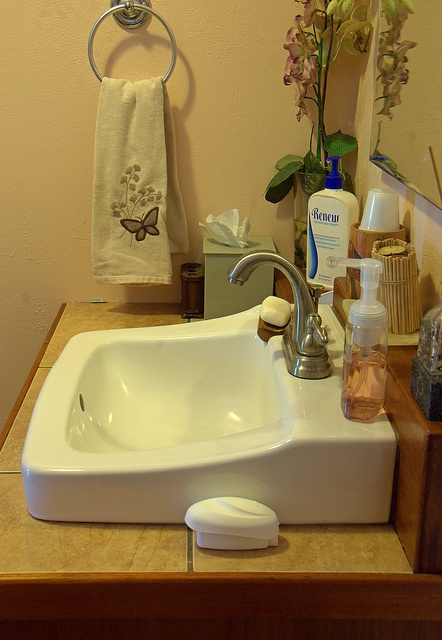Describe the objects in this image and their specific colors. I can see sink in tan, khaki, and gray tones, bottle in tan, brown, darkgray, and gray tones, bottle in tan and navy tones, vase in tan, olive, and black tones, and cup in tan, darkgray, olive, and khaki tones in this image. 